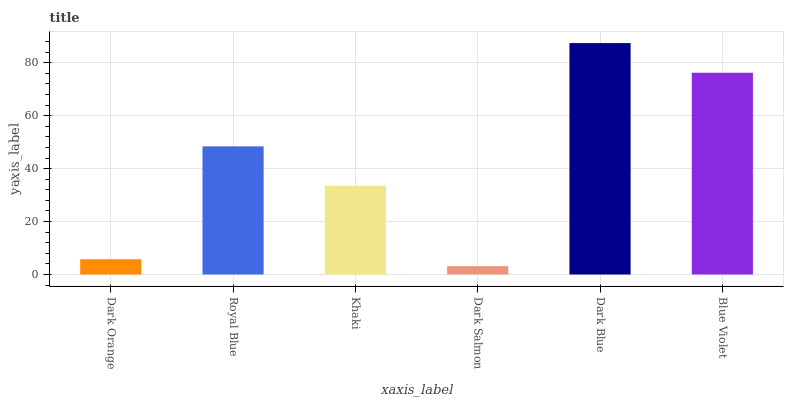Is Royal Blue the minimum?
Answer yes or no. No. Is Royal Blue the maximum?
Answer yes or no. No. Is Royal Blue greater than Dark Orange?
Answer yes or no. Yes. Is Dark Orange less than Royal Blue?
Answer yes or no. Yes. Is Dark Orange greater than Royal Blue?
Answer yes or no. No. Is Royal Blue less than Dark Orange?
Answer yes or no. No. Is Royal Blue the high median?
Answer yes or no. Yes. Is Khaki the low median?
Answer yes or no. Yes. Is Dark Salmon the high median?
Answer yes or no. No. Is Dark Orange the low median?
Answer yes or no. No. 